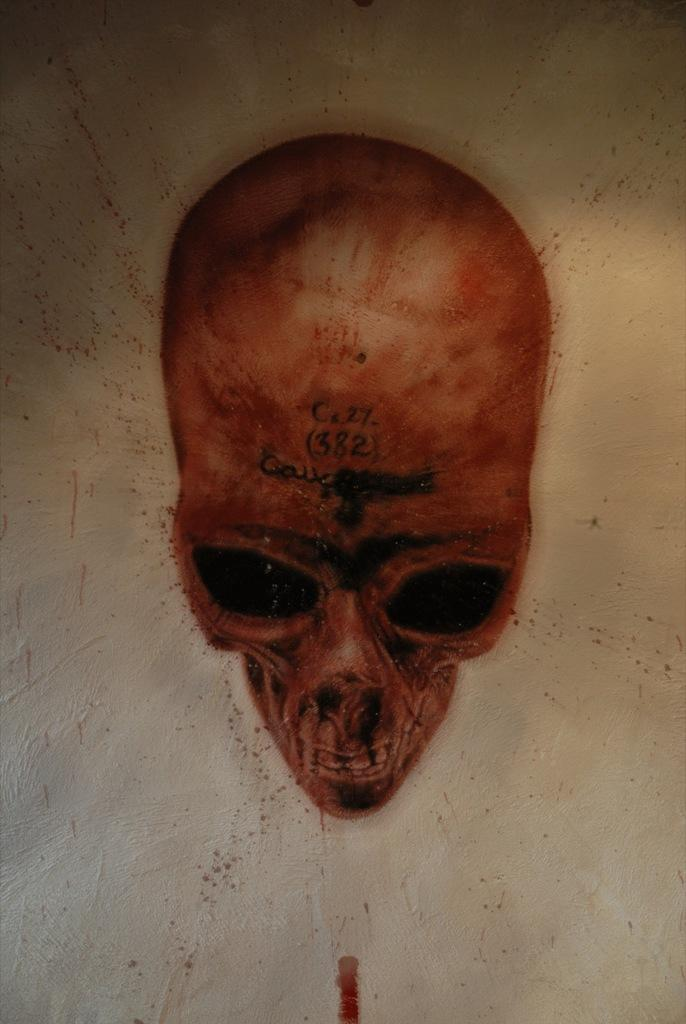What is the main subject of the image? There is a painting in the image. What does the painting depict? The painting depicts a skull. How many pizzas are shown in the painting? There are no pizzas depicted in the painting; it features a skull. What type of footwear is shown next to the skull in the painting? There is no footwear shown next to the skull in the painting; it only depicts a skull. 